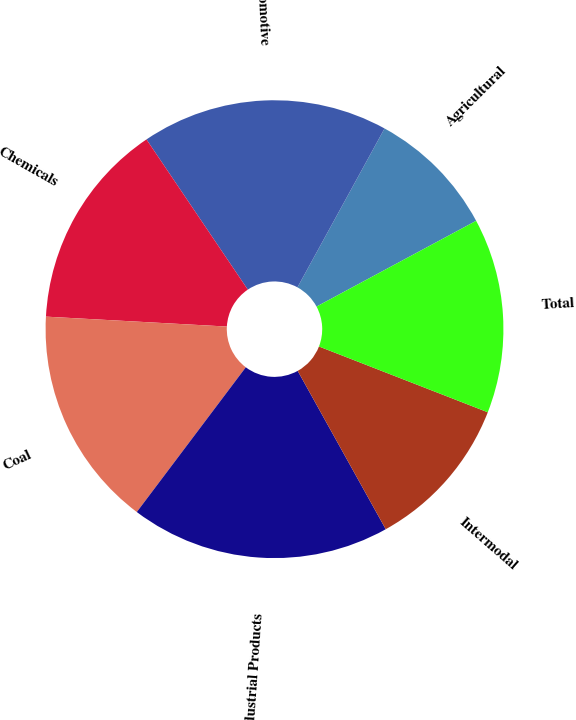<chart> <loc_0><loc_0><loc_500><loc_500><pie_chart><fcel>Agricultural<fcel>Automotive<fcel>Chemicals<fcel>Coal<fcel>Industrial Products<fcel>Intermodal<fcel>Total<nl><fcel>9.17%<fcel>17.43%<fcel>14.68%<fcel>15.6%<fcel>18.35%<fcel>11.01%<fcel>13.76%<nl></chart> 